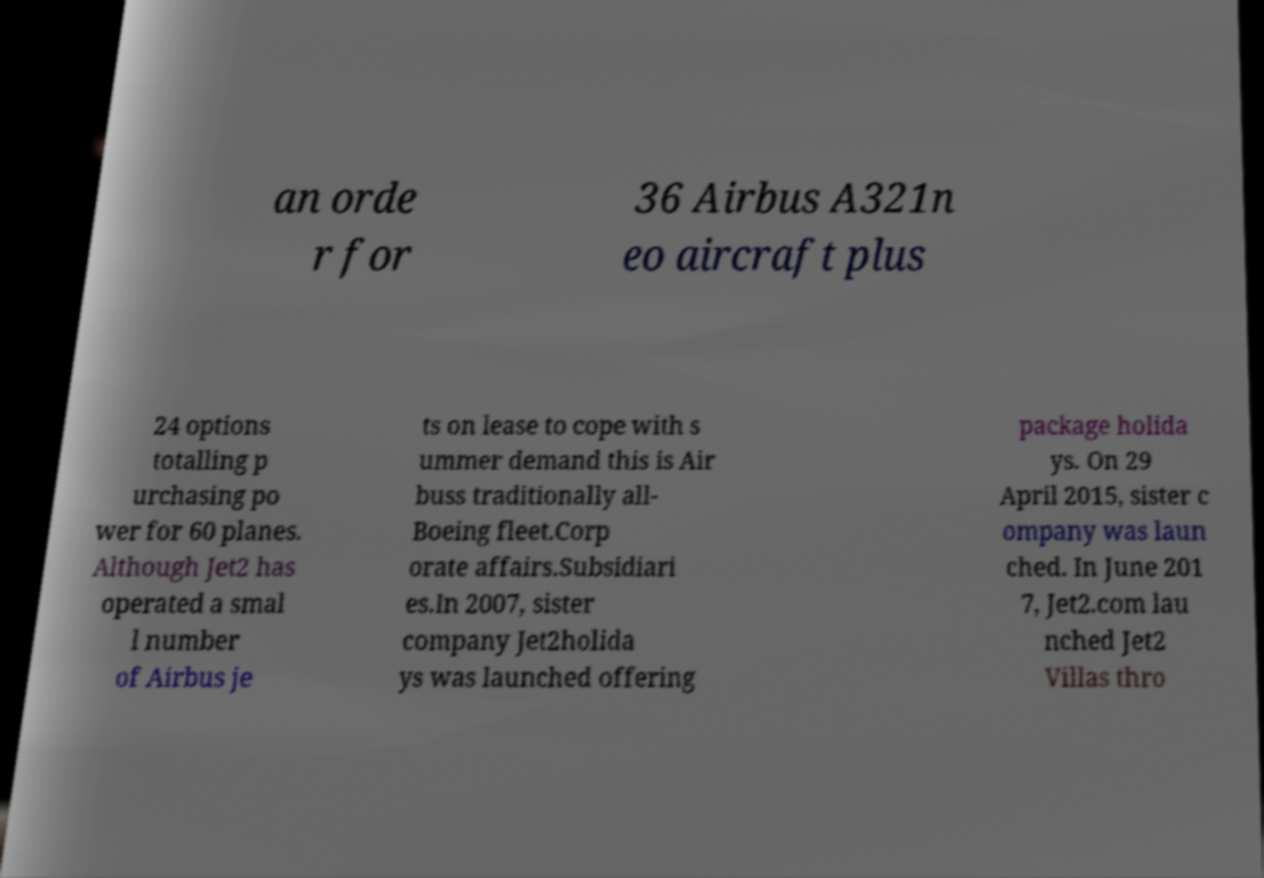Could you extract and type out the text from this image? an orde r for 36 Airbus A321n eo aircraft plus 24 options totalling p urchasing po wer for 60 planes. Although Jet2 has operated a smal l number of Airbus je ts on lease to cope with s ummer demand this is Air buss traditionally all- Boeing fleet.Corp orate affairs.Subsidiari es.In 2007, sister company Jet2holida ys was launched offering package holida ys. On 29 April 2015, sister c ompany was laun ched. In June 201 7, Jet2.com lau nched Jet2 Villas thro 